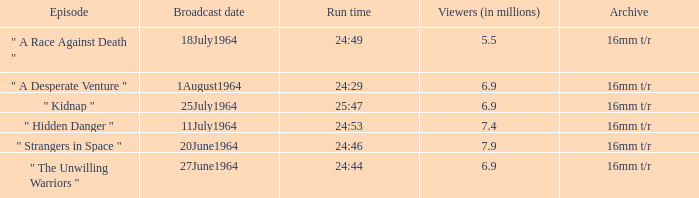What episode aired on 11july1964? " Hidden Danger ". 